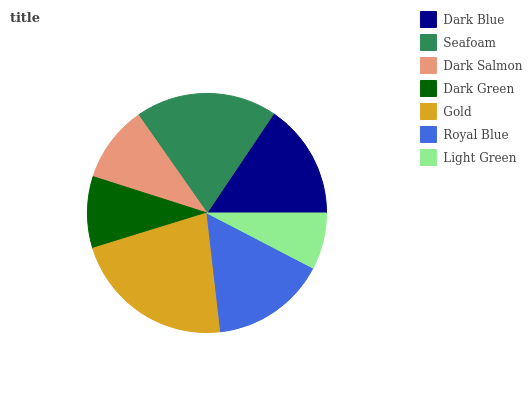Is Light Green the minimum?
Answer yes or no. Yes. Is Gold the maximum?
Answer yes or no. Yes. Is Seafoam the minimum?
Answer yes or no. No. Is Seafoam the maximum?
Answer yes or no. No. Is Seafoam greater than Dark Blue?
Answer yes or no. Yes. Is Dark Blue less than Seafoam?
Answer yes or no. Yes. Is Dark Blue greater than Seafoam?
Answer yes or no. No. Is Seafoam less than Dark Blue?
Answer yes or no. No. Is Royal Blue the high median?
Answer yes or no. Yes. Is Royal Blue the low median?
Answer yes or no. Yes. Is Seafoam the high median?
Answer yes or no. No. Is Gold the low median?
Answer yes or no. No. 